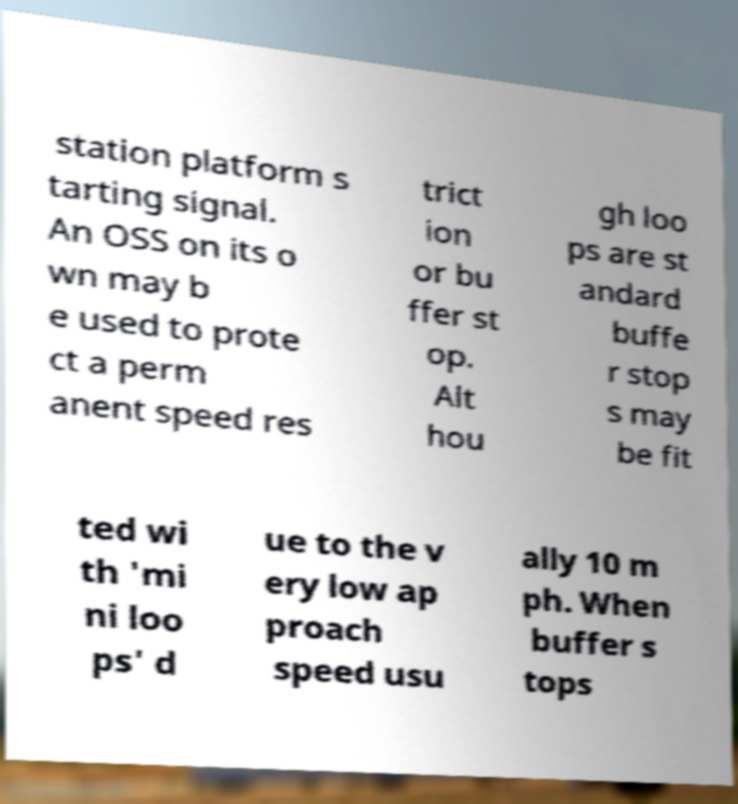Please read and relay the text visible in this image. What does it say? station platform s tarting signal. An OSS on its o wn may b e used to prote ct a perm anent speed res trict ion or bu ffer st op. Alt hou gh loo ps are st andard buffe r stop s may be fit ted wi th 'mi ni loo ps' d ue to the v ery low ap proach speed usu ally 10 m ph. When buffer s tops 